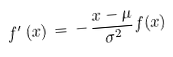<formula> <loc_0><loc_0><loc_500><loc_500>f ^ { \prime } \, ( x ) \, = \, - \, { \frac { x - \mu } { \sigma ^ { 2 } } } f ( x )</formula> 